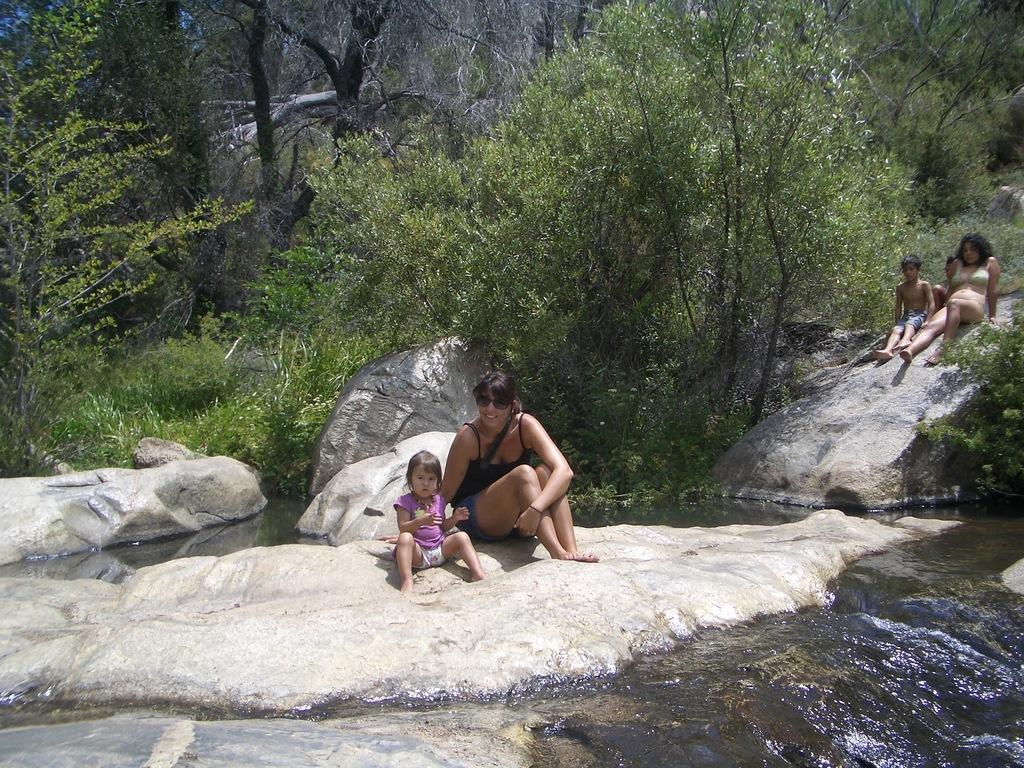What are the people in the image doing? The people in the image are sitting on rocks. Can you describe the clothing or accessories of any of the people? One person is wearing goggles. What is the natural environment like in the image? There is water visible near the people, and there are many trees in the image. What type of expansion can be seen in the image? There is no expansion visible in the image; it features people sitting on rocks near water and trees. 